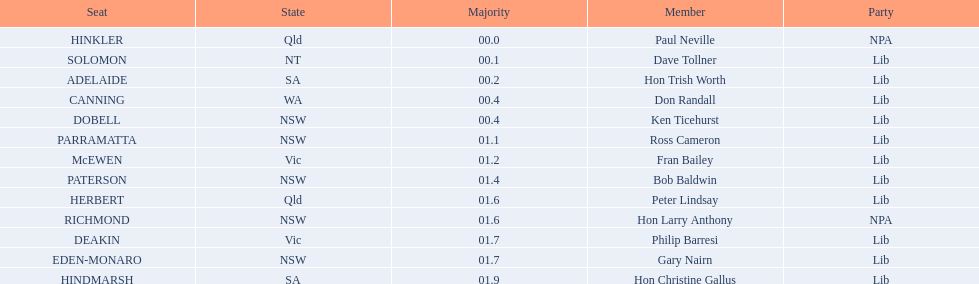What state does hinkler belong too? Qld. What is the majority of difference between sa and qld? 01.9. 